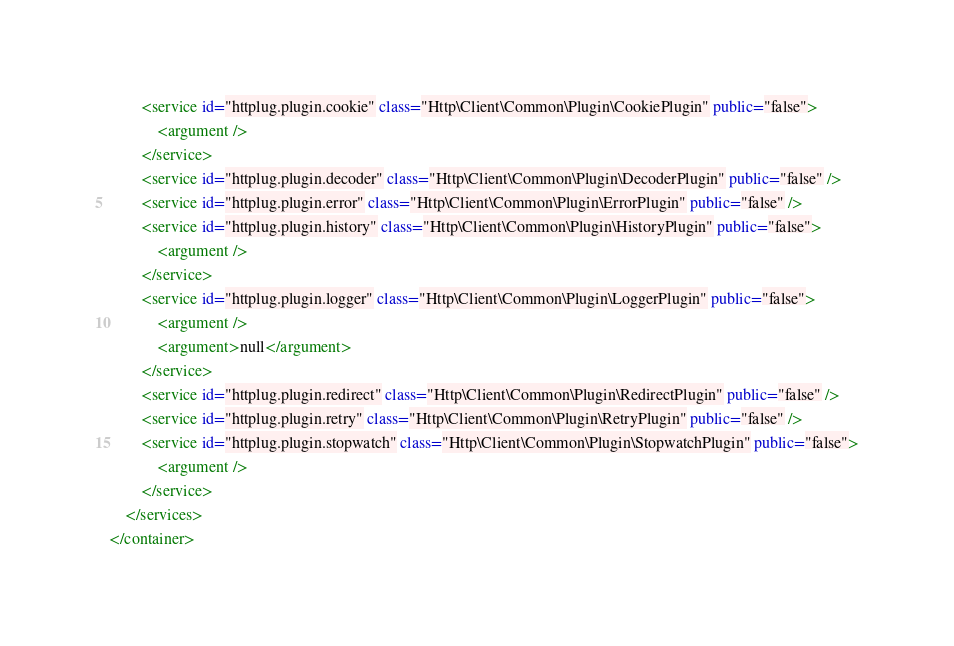Convert code to text. <code><loc_0><loc_0><loc_500><loc_500><_XML_>        <service id="httplug.plugin.cookie" class="Http\Client\Common\Plugin\CookiePlugin" public="false">
            <argument />
        </service>
        <service id="httplug.plugin.decoder" class="Http\Client\Common\Plugin\DecoderPlugin" public="false" />
        <service id="httplug.plugin.error" class="Http\Client\Common\Plugin\ErrorPlugin" public="false" />
        <service id="httplug.plugin.history" class="Http\Client\Common\Plugin\HistoryPlugin" public="false">
            <argument />
        </service>
        <service id="httplug.plugin.logger" class="Http\Client\Common\Plugin\LoggerPlugin" public="false">
            <argument />
            <argument>null</argument>
        </service>
        <service id="httplug.plugin.redirect" class="Http\Client\Common\Plugin\RedirectPlugin" public="false" />
        <service id="httplug.plugin.retry" class="Http\Client\Common\Plugin\RetryPlugin" public="false" />
        <service id="httplug.plugin.stopwatch" class="Http\Client\Common\Plugin\StopwatchPlugin" public="false">
            <argument />
        </service>
    </services>
</container>
</code> 